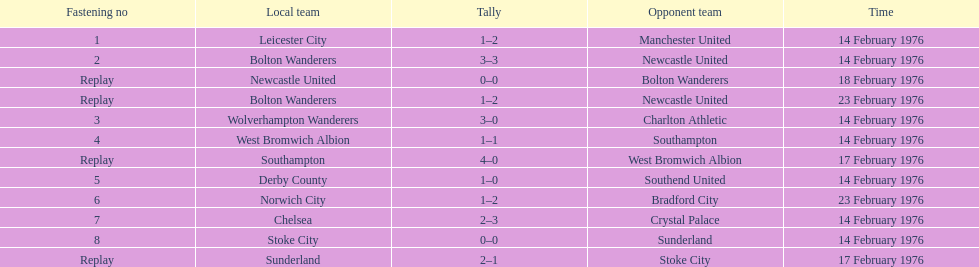Which squads participated the same day as leicester city and manchester united? Bolton Wanderers, Newcastle United. 